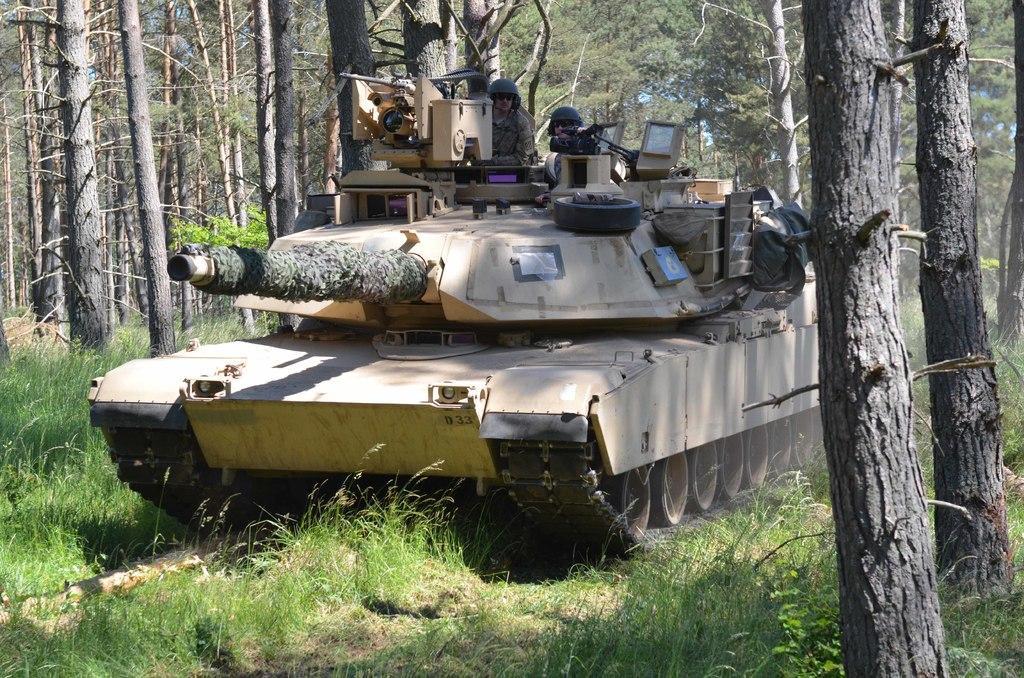Can you describe this image briefly? This is a tanker, these are trees. 